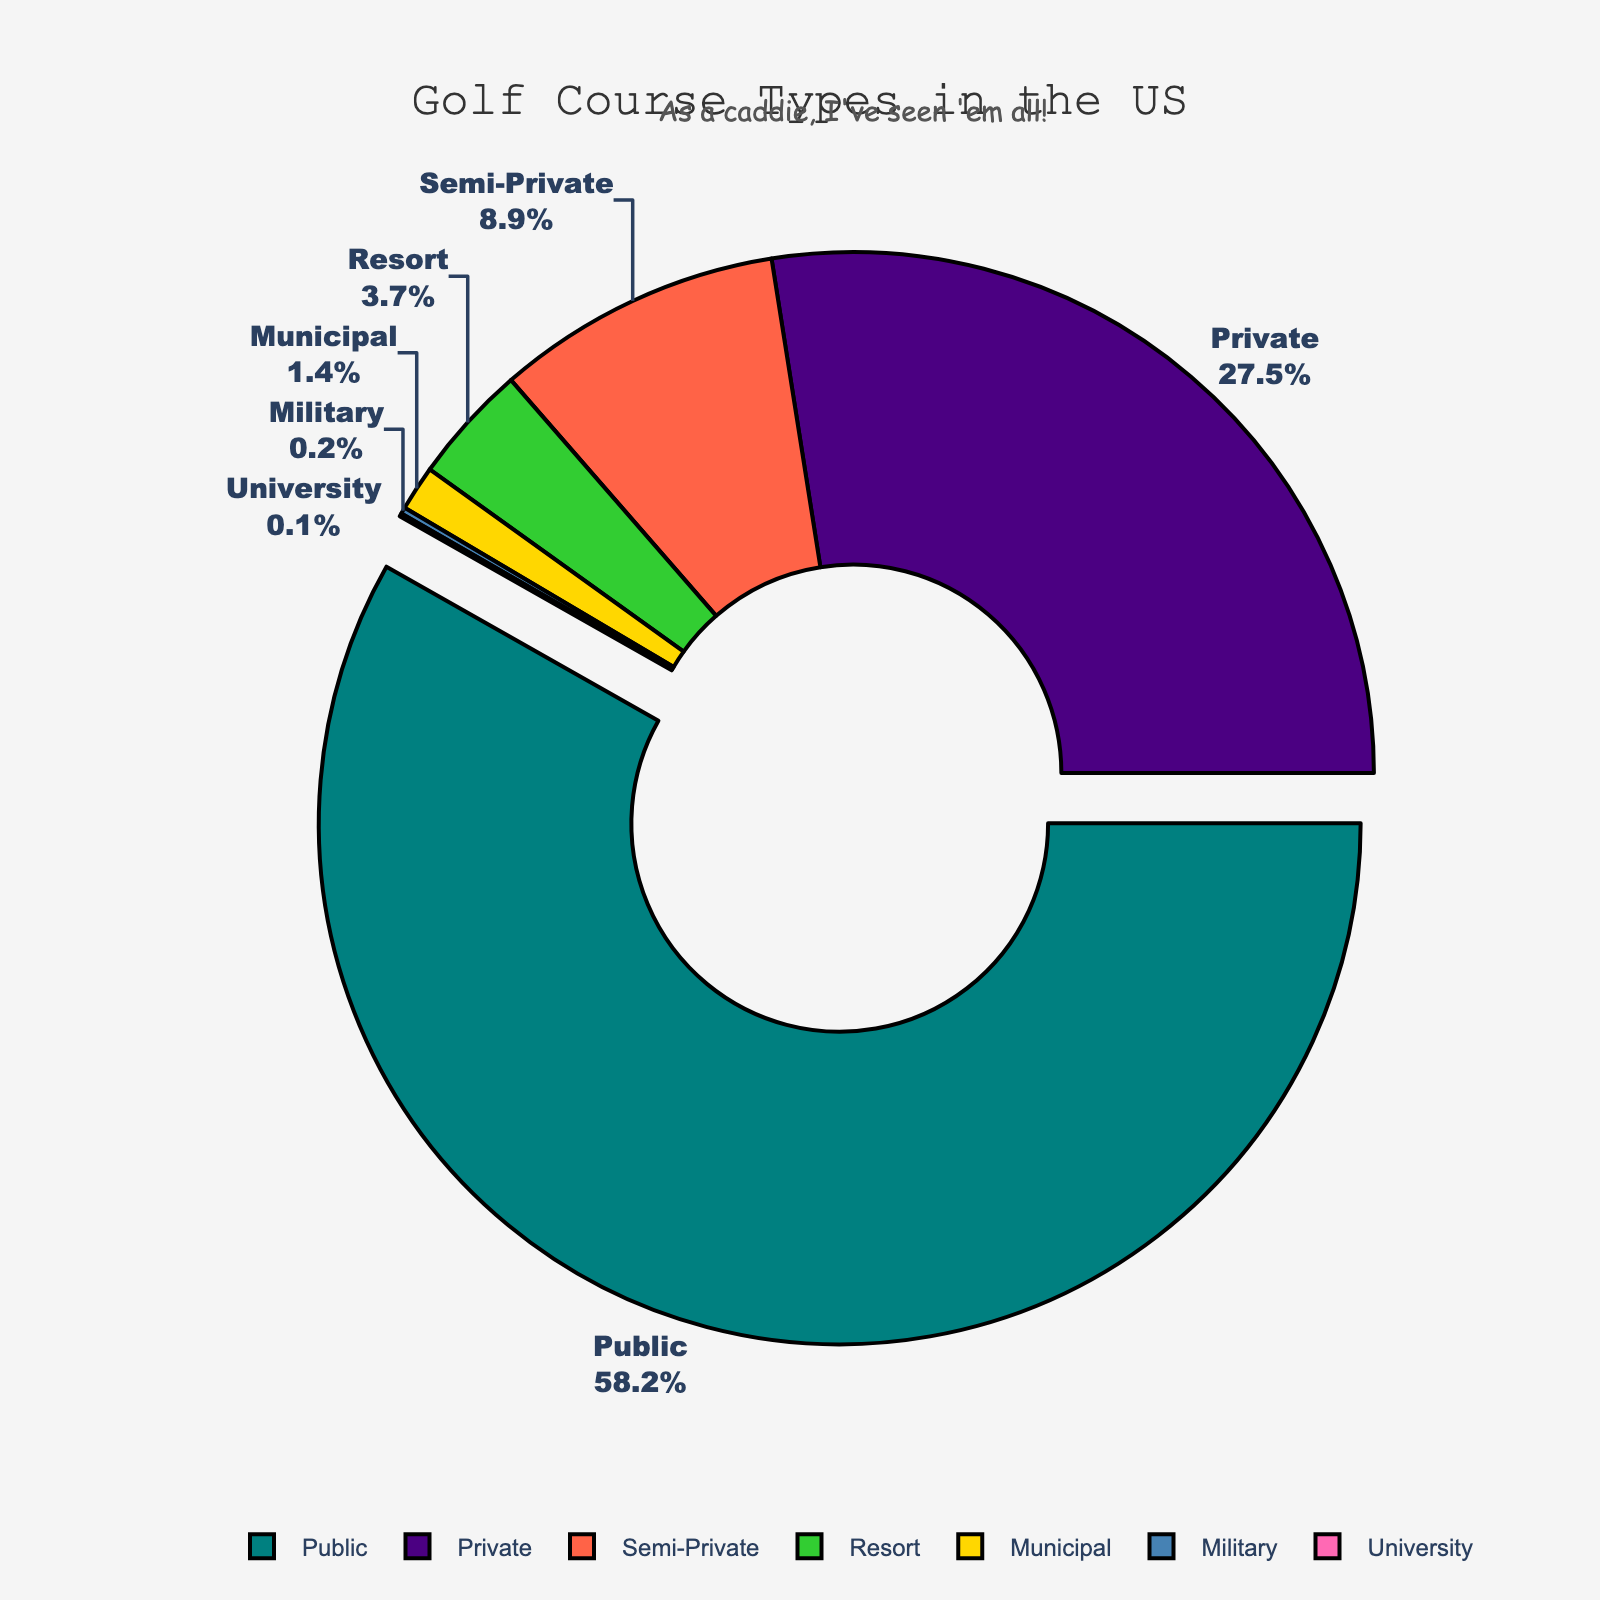What percentage of golf courses in the US are public and semi-private combined? Sum the percentages of public (58.2%) and semi-private (8.9%) courses: 58.2% + 8.9% = 67.1%
Answer: 67.1% Between private and resort golf courses, which type represents a higher percentage? Compare the percentages of private (27.5%) and resort (3.7%) courses. Since 27.5% is greater than 3.7%, private has a higher percentage.
Answer: Private What is the percentage difference between municipal and military golf courses? Subtract the percentage of military (0.2%) from municipal (1.4%): 1.4% - 0.2% = 1.2%
Answer: 1.2% Which golf course type has the smallest percentage, and what is it? Identify the smallest value on the chart, which is university at 0.1%
Answer: University, 0.1% How much more common are public golf courses compared to private ones? Subtract the percentage of private (27.5%) from public (58.2%): 58.2% - 27.5% = 30.7%
Answer: 30.7% What portion of the total golf courses do municipal and university courses together represent? Sum the percentages of municipal (1.4%) and university (0.1%) courses: 1.4% + 0.1% = 1.5%
Answer: 1.5% Among public, private, and semi-private courses, which type occupies the largest portion, and how much larger is it than semi-private? Identify the largest percentage among public (58.2%), private (27.5%), and semi-private (8.9%): Public at 58.2%. Subtract the percentage of semi-private (8.9%) from public: 58.2% - 8.9% = 49.3%
Answer: Public, 49.3% What colors are used to represent the military and resort golf courses in the chart? Identify the colors visually assigned to military and resort. Military is light blue, and resort is lime green.
Answer: Light blue, lime green Which golf course type sits at the second-highest position on the legend, and what is its percentage? Check the second position on the legend which is private golf courses at 27.5%
Answer: Private, 27.5% 